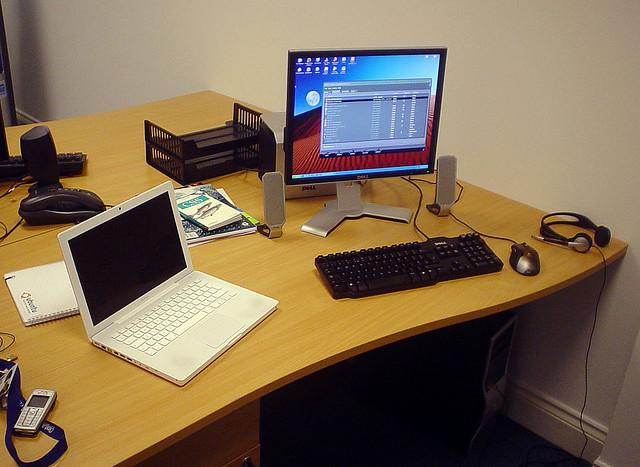What are the two standing rectangular devices? speakers 